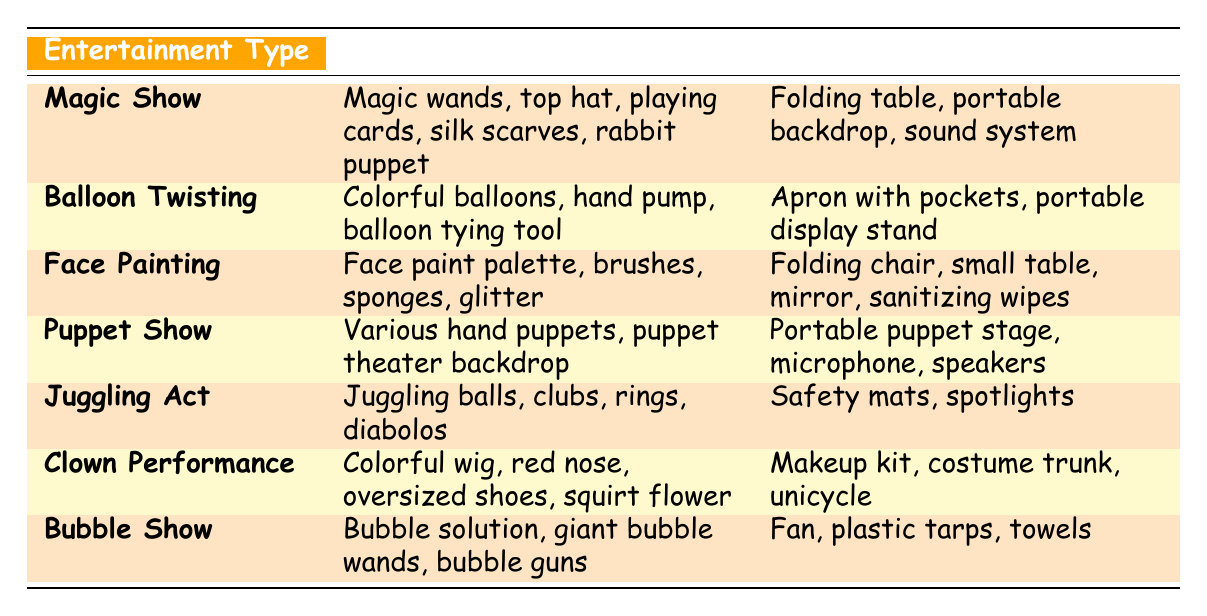What props are used in a Juggling Act? The table lists the props used in a Juggling Act as juggling balls, clubs, rings, and diabolos.
Answer: Juggling balls, clubs, rings, diabolos Which entertainment type uses a portable puppet stage? The Puppet Show is listed in the table under the Entertainment Type category, and it mentions that it requires a portable puppet stage as equipment.
Answer: Puppet Show Are there any performances that require a fan as part of their equipment? Yes, the Bubble Show includes a fan as part of the equipment necessary for the performance, as indicated in the table.
Answer: Yes What is the total number of props required for both a Magic Show and a Clown Performance? The Magic Show requires 5 props and the Clown Performance has 4 props, so the total is 5 + 4 = 9 props.
Answer: 9 Does Face Painting use glitter in its props? Yes, the Face Painting entertainment type explicitly lists glitter among its props in the table.
Answer: Yes Which entertainment type has the most props listed? By analyzing the table, the Magic Show has the highest number of props, totaling 5, while other types have fewer.
Answer: Magic Show What equipment do you need for Face Painting? According to the table, Face Painting requires a folding chair, small table, mirror, and sanitizing wipes.
Answer: Folding chair, small table, mirror, sanitizing wipes How many types of entertainment require a backdrop? The Magic Show and Puppet Show both require backdrops as specified in their respective entries in the table, resulting in 2 types of entertainment.
Answer: 2 Which entertainment types use colorful items as props? The Balloon Twisting and Clown Performance both feature colorful items in their props: colorful balloons and a colorful wig, respectively.
Answer: Balloon Twisting, Clown Performance Is there any performance listed that does not use a table? Yes, the Juggling Act does not mention using a table in its equipment, as outlined in the table.
Answer: Yes 